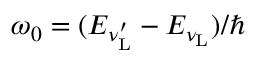<formula> <loc_0><loc_0><loc_500><loc_500>\omega _ { 0 } = ( E _ { \nu _ { L } ^ { \prime } } - E _ { \nu _ { L } } ) / \hbar</formula> 